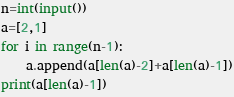Convert code to text. <code><loc_0><loc_0><loc_500><loc_500><_Python_>n=int(input())
a=[2,1]
for i in range(n-1):
    a.append(a[len(a)-2]+a[len(a)-1])
print(a[len(a)-1])</code> 